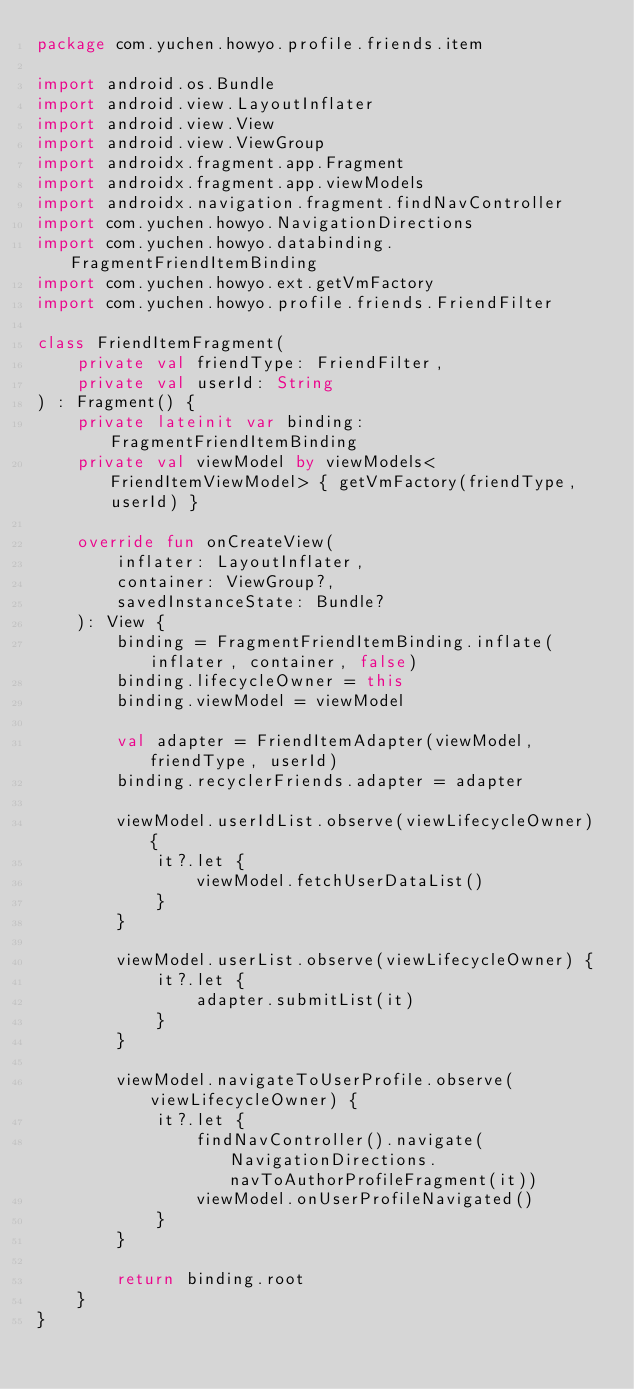<code> <loc_0><loc_0><loc_500><loc_500><_Kotlin_>package com.yuchen.howyo.profile.friends.item

import android.os.Bundle
import android.view.LayoutInflater
import android.view.View
import android.view.ViewGroup
import androidx.fragment.app.Fragment
import androidx.fragment.app.viewModels
import androidx.navigation.fragment.findNavController
import com.yuchen.howyo.NavigationDirections
import com.yuchen.howyo.databinding.FragmentFriendItemBinding
import com.yuchen.howyo.ext.getVmFactory
import com.yuchen.howyo.profile.friends.FriendFilter

class FriendItemFragment(
    private val friendType: FriendFilter,
    private val userId: String
) : Fragment() {
    private lateinit var binding: FragmentFriendItemBinding
    private val viewModel by viewModels<FriendItemViewModel> { getVmFactory(friendType, userId) }

    override fun onCreateView(
        inflater: LayoutInflater,
        container: ViewGroup?,
        savedInstanceState: Bundle?
    ): View {
        binding = FragmentFriendItemBinding.inflate(inflater, container, false)
        binding.lifecycleOwner = this
        binding.viewModel = viewModel

        val adapter = FriendItemAdapter(viewModel, friendType, userId)
        binding.recyclerFriends.adapter = adapter

        viewModel.userIdList.observe(viewLifecycleOwner) {
            it?.let {
                viewModel.fetchUserDataList()
            }
        }

        viewModel.userList.observe(viewLifecycleOwner) {
            it?.let {
                adapter.submitList(it)
            }
        }

        viewModel.navigateToUserProfile.observe(viewLifecycleOwner) {
            it?.let {
                findNavController().navigate(NavigationDirections.navToAuthorProfileFragment(it))
                viewModel.onUserProfileNavigated()
            }
        }

        return binding.root
    }
}
</code> 